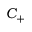<formula> <loc_0><loc_0><loc_500><loc_500>C _ { + }</formula> 